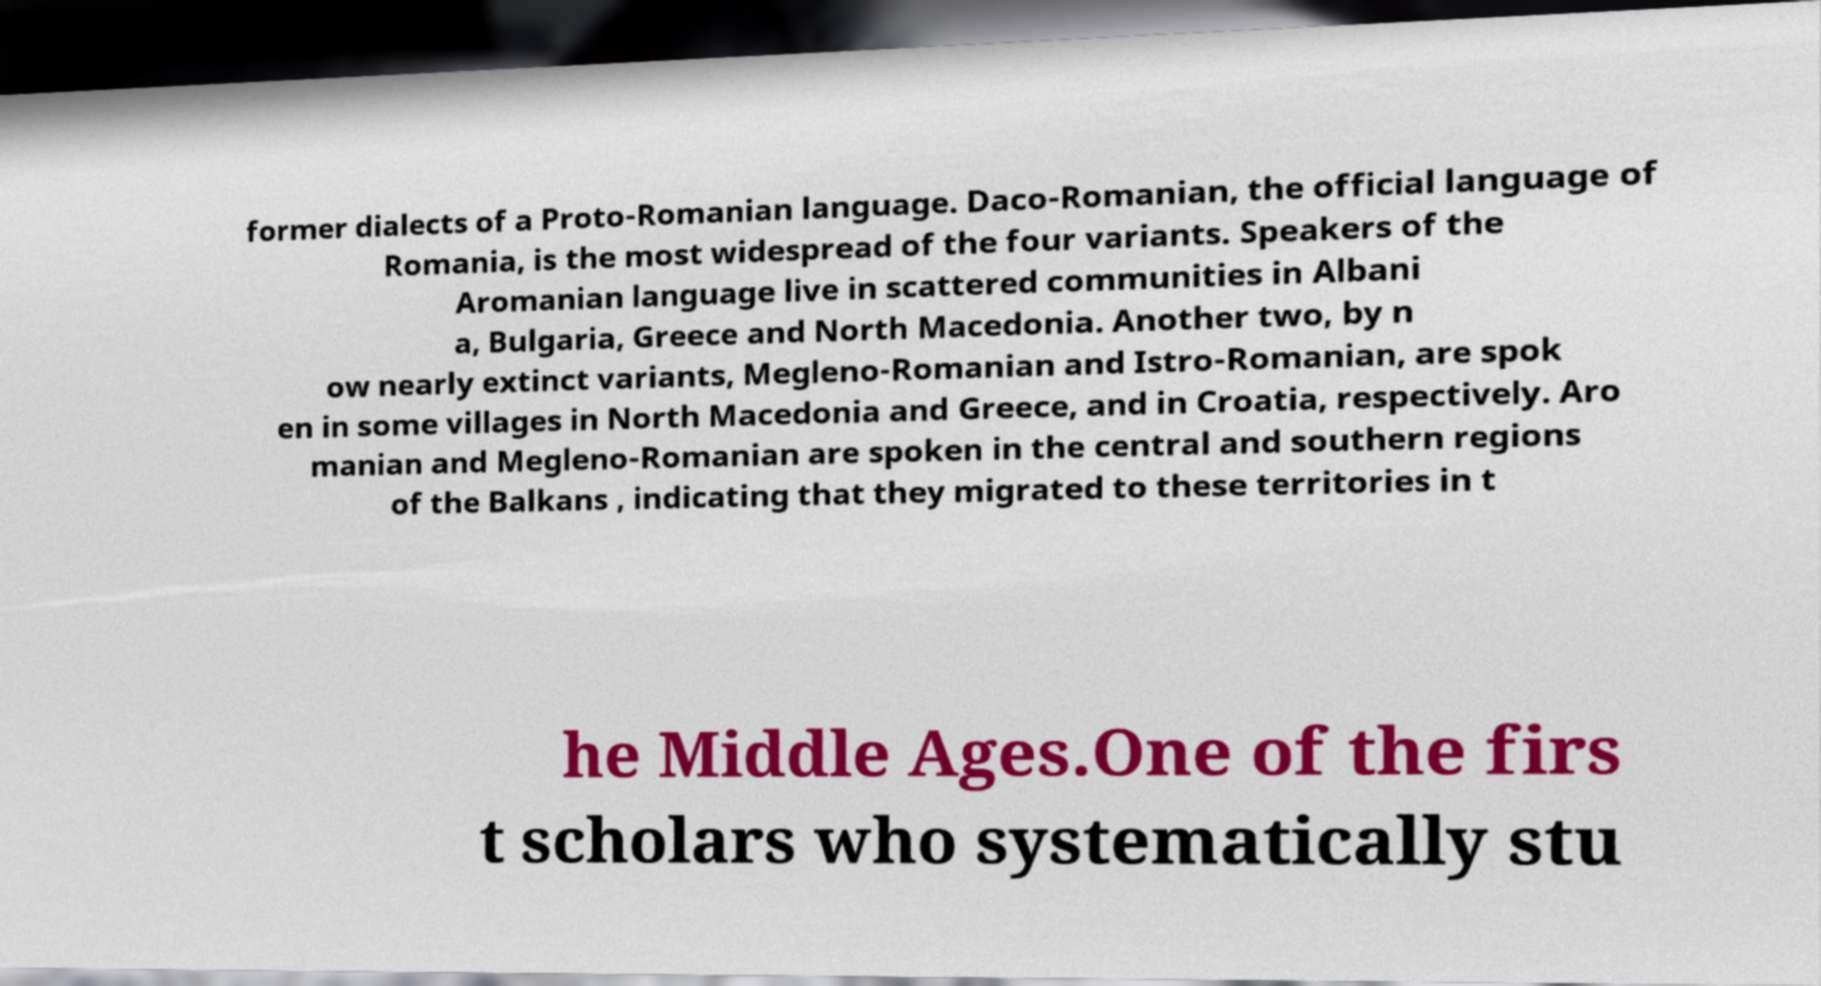Could you assist in decoding the text presented in this image and type it out clearly? former dialects of a Proto-Romanian language. Daco-Romanian, the official language of Romania, is the most widespread of the four variants. Speakers of the Aromanian language live in scattered communities in Albani a, Bulgaria, Greece and North Macedonia. Another two, by n ow nearly extinct variants, Megleno-Romanian and Istro-Romanian, are spok en in some villages in North Macedonia and Greece, and in Croatia, respectively. Aro manian and Megleno-Romanian are spoken in the central and southern regions of the Balkans , indicating that they migrated to these territories in t he Middle Ages.One of the firs t scholars who systematically stu 